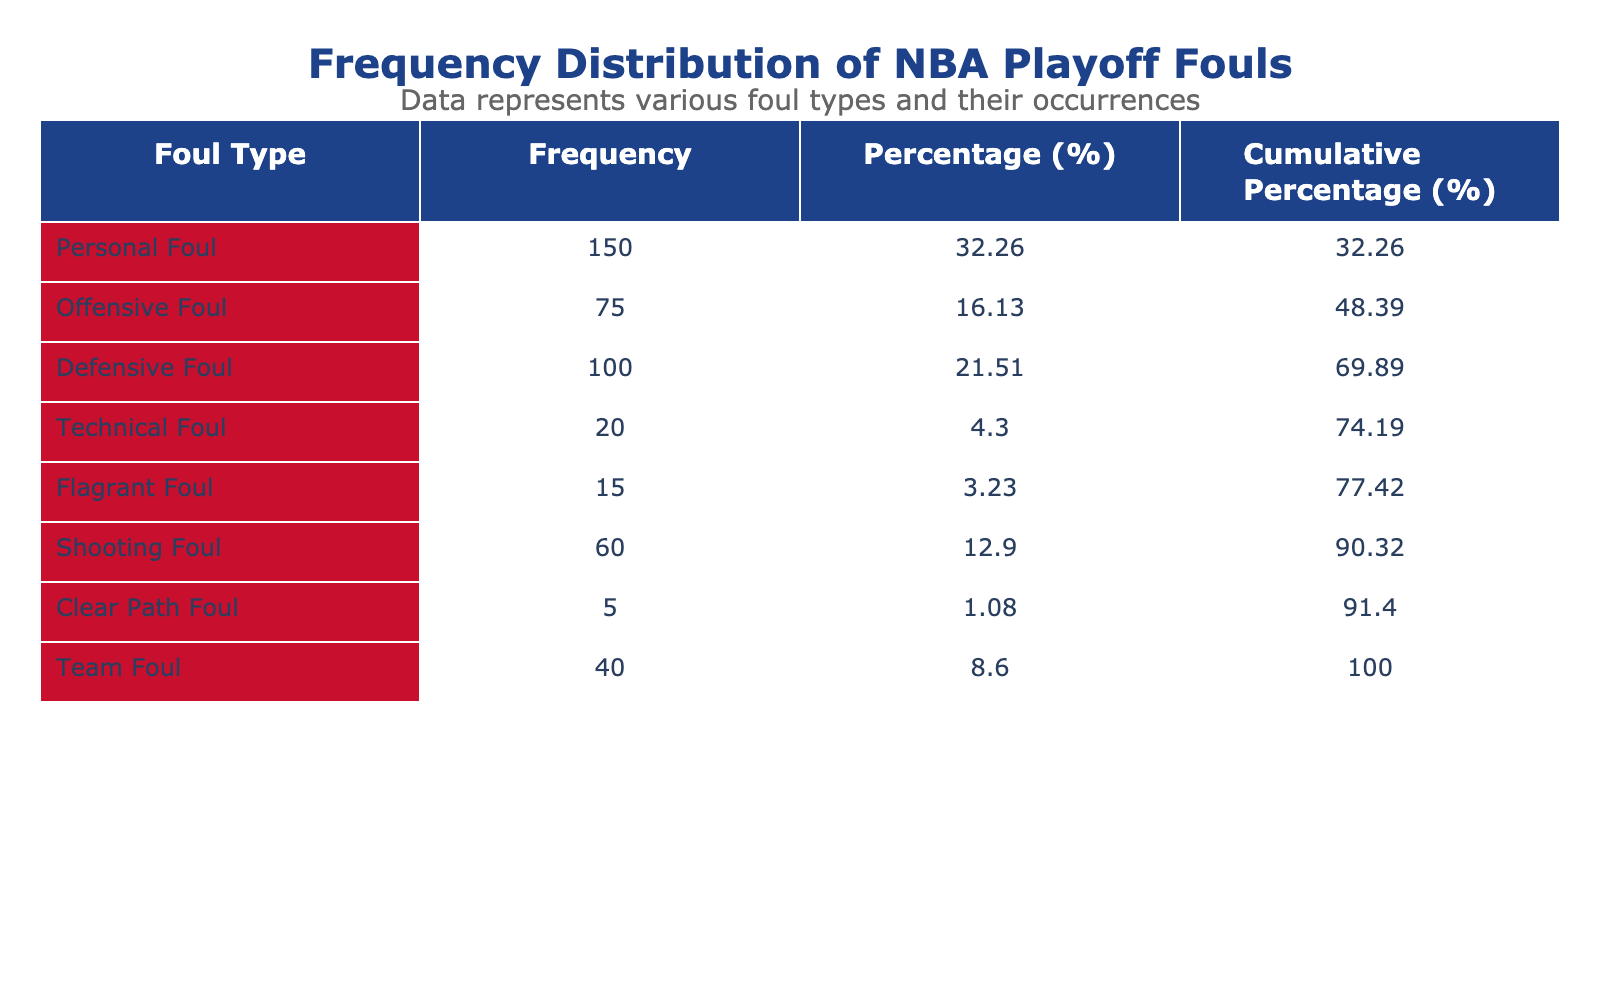What is the frequency of Personal Fouls? The table indicates that Personal Fouls have a frequency of 150. This is a direct retrieval from the "Frequency" column under "Personal Foul."
Answer: 150 What is the cumulative percentage of Technical Fouls? The cumulative percentage for Technical Fouls can be found in the "Cumulative Percentage" column. Technical Fouls have a frequency of 20, and the cumulative total for the fouls that precede it (adding Personal Foul, Offensive Foul, Defensive Foul, and Shooting Foul) gives (150 + 75 + 100 + 60 + 20) = 405. Hence, the cumulative percentage is 20/405 * 100 which approximately equals 4.94, rounded to two decimal places results in 4.94.
Answer: 4.94 Which foul type has the lowest frequency? By scanning through the "Frequency" column, Clear Path Foul has the lowest frequency of 5, which is less than any other foul type.
Answer: Clear Path Foul What percentage of fouls are Technical Fouls? The frequency of Technical Fouls is 20. To find the percentage, we need to calculate (20/500) * 100, where 500 is the total frequency of all fouls (sum of 150 + 75 + 100 + 20 + 15 + 60 + 5 + 40). This results in a percentage of 4.00.
Answer: 4.00 Is the frequency of Offensive Fouls greater than Defensive Fouls? Offensive Fouls have a frequency of 75 while Defensive Fouls have a frequency of 100. Since 75 is not greater than 100, the answer is no.
Answer: No What is the sum of frequencies for all types of fouls? To find the sum of all fouls, we add the frequencies: 150 + 75 + 100 + 20 + 15 + 60 + 5 + 40 = 500. This is a basic arithmetic addition of all the provided frequencies.
Answer: 500 What is the average frequency of all foul types? The average frequency is calculated by taking the total frequency (500) and dividing it by the number of foul types (8), which gives us 500/8 = 62.5. This is a basic division operation averaging out the frequencies.
Answer: 62.5 Which foul type constitutes the largest percentage of total fouls? Personal Foul has a frequency of 150. To find its percentage, we calculate (150/500) * 100 = 30%. After checking other types, Personal Foul indeed has the largest percentage compared to others.
Answer: Personal Foul What is the difference in frequency between Defensive Fouls and Team Fouls? Defensive Fouls have a frequency of 100 and Team Fouls have a frequency of 40. To find the difference, we subtract: 100 - 40 = 60. This is a simple subtraction of the two frequencies.
Answer: 60 